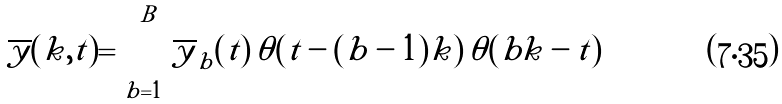<formula> <loc_0><loc_0><loc_500><loc_500>\overline { y } ( k , t ) = \sum _ { b = 1 } ^ { B } \overline { y } _ { b } ( t ) \, \theta ( t - ( b - 1 ) k ) \, \theta ( b k - t )</formula> 